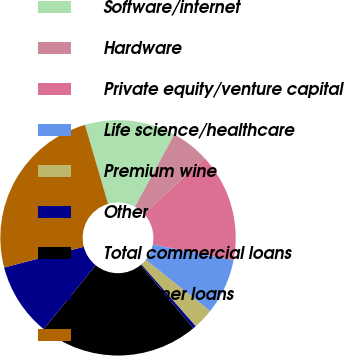Convert chart. <chart><loc_0><loc_0><loc_500><loc_500><pie_chart><fcel>Software/internet<fcel>Hardware<fcel>Private equity/venture capital<fcel>Life science/healthcare<fcel>Premium wine<fcel>Other<fcel>Total commercial loans<fcel>Consumer loans<fcel>Total<nl><fcel>12.47%<fcel>5.24%<fcel>14.88%<fcel>7.65%<fcel>2.83%<fcel>0.42%<fcel>21.93%<fcel>10.06%<fcel>24.53%<nl></chart> 